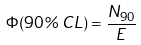<formula> <loc_0><loc_0><loc_500><loc_500>\Phi ( 9 0 \% \, C L ) = \frac { N _ { 9 0 } } { E }</formula> 